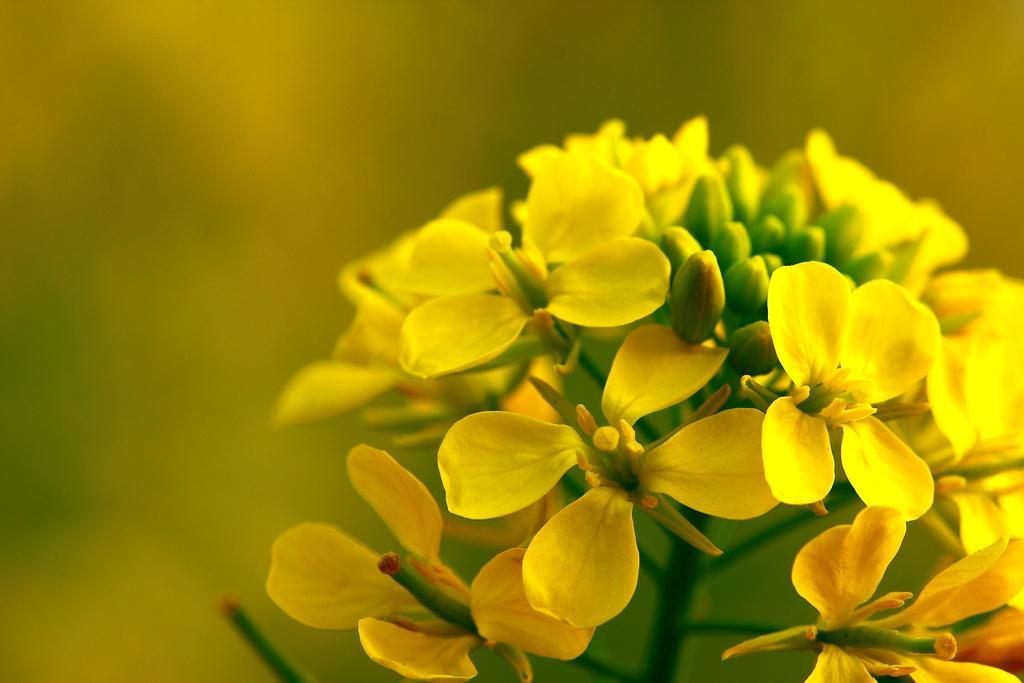How would you summarize this image in a sentence or two? In this image we can see flowers which are in yellow color. 